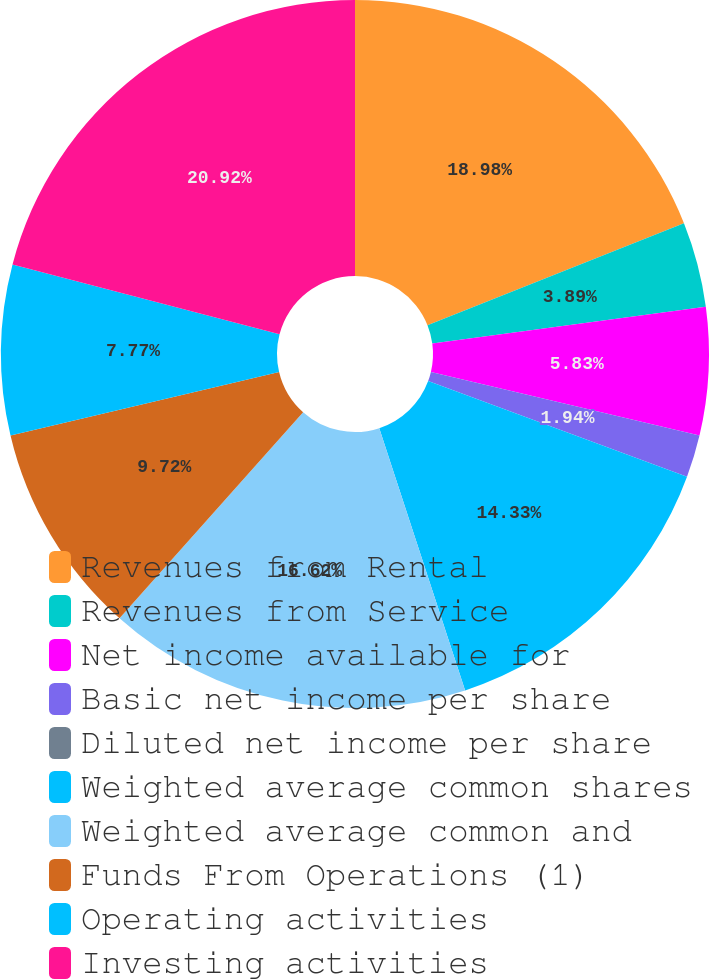Convert chart. <chart><loc_0><loc_0><loc_500><loc_500><pie_chart><fcel>Revenues from Rental<fcel>Revenues from Service<fcel>Net income available for<fcel>Basic net income per share<fcel>Diluted net income per share<fcel>Weighted average common shares<fcel>Weighted average common and<fcel>Funds From Operations (1)<fcel>Operating activities<fcel>Investing activities<nl><fcel>18.98%<fcel>3.89%<fcel>5.83%<fcel>1.94%<fcel>0.0%<fcel>14.33%<fcel>16.62%<fcel>9.72%<fcel>7.77%<fcel>20.93%<nl></chart> 